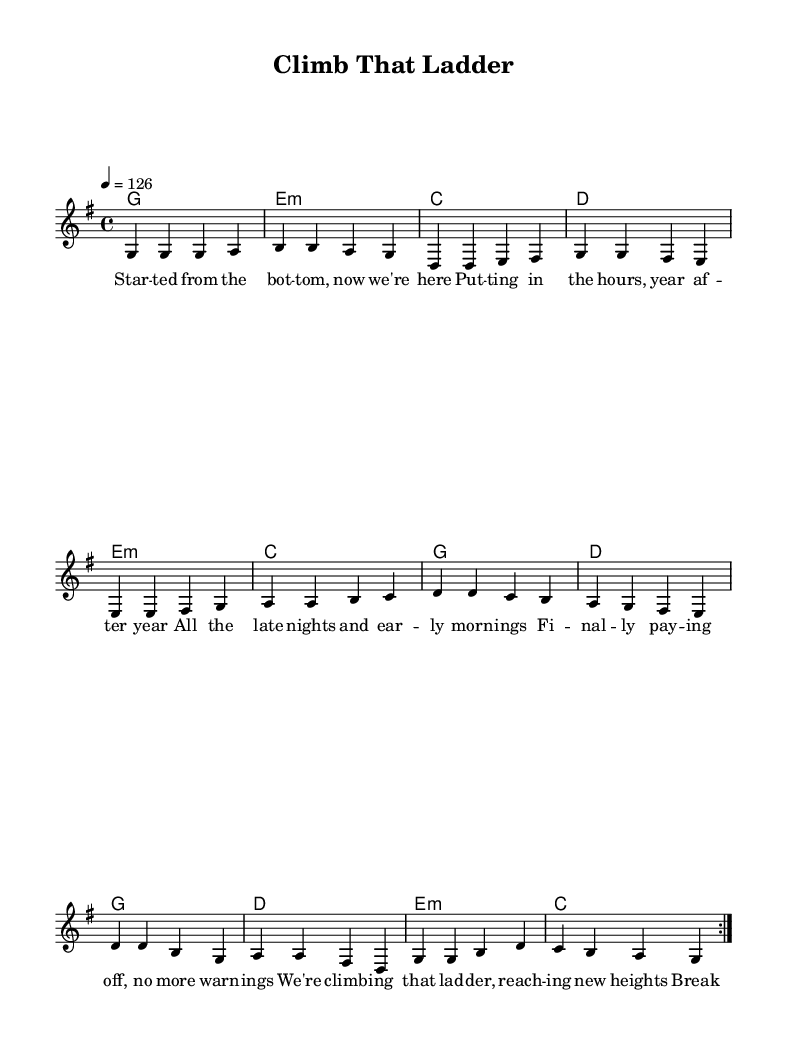What is the key signature of this music? The key signature appears at the beginning of the score, indicating G major, which has one sharp.
Answer: G major What is the time signature of this piece? The time signature is shown at the beginning of the score; it is 4/4, meaning there are four beats in each measure.
Answer: 4/4 What is the tempo marking for this music? The tempo is indicated by the number "126" at the beginning, which denotes 126 beats per minute.
Answer: 126 How many measures are repeated in the verse? The verse section shows a repeat indication with the word "volta" followed by the number 2, meaning two measures are repeated.
Answer: 2 What emotions does this upbeat anthem reflect? The lyrics mention "climbing that ladder" and "breaking through barriers," suggesting themes of success and achievement typically found in upbeat pop anthems.
Answer: Success What are the primary chord changes in this piece? The chord changes in the harmony section start with G, followed by E minor, C, and D, displaying a common pop chord progression.
Answer: G, E minor, C, D Which lines in the lyrics emphasize hard work? The lyrics like "putting in the hours, year after year" and "all the late nights and early mornings" highlight the dedication and effort involved in achieving success.
Answer: "Putting in the hours, year after year" 